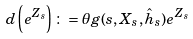<formula> <loc_0><loc_0><loc_500><loc_500>d \left ( e ^ { Z _ { s } } \right ) \colon = \theta g ( s , X _ { s } , \hat { h } _ { s } ) e ^ { Z _ { s } }</formula> 